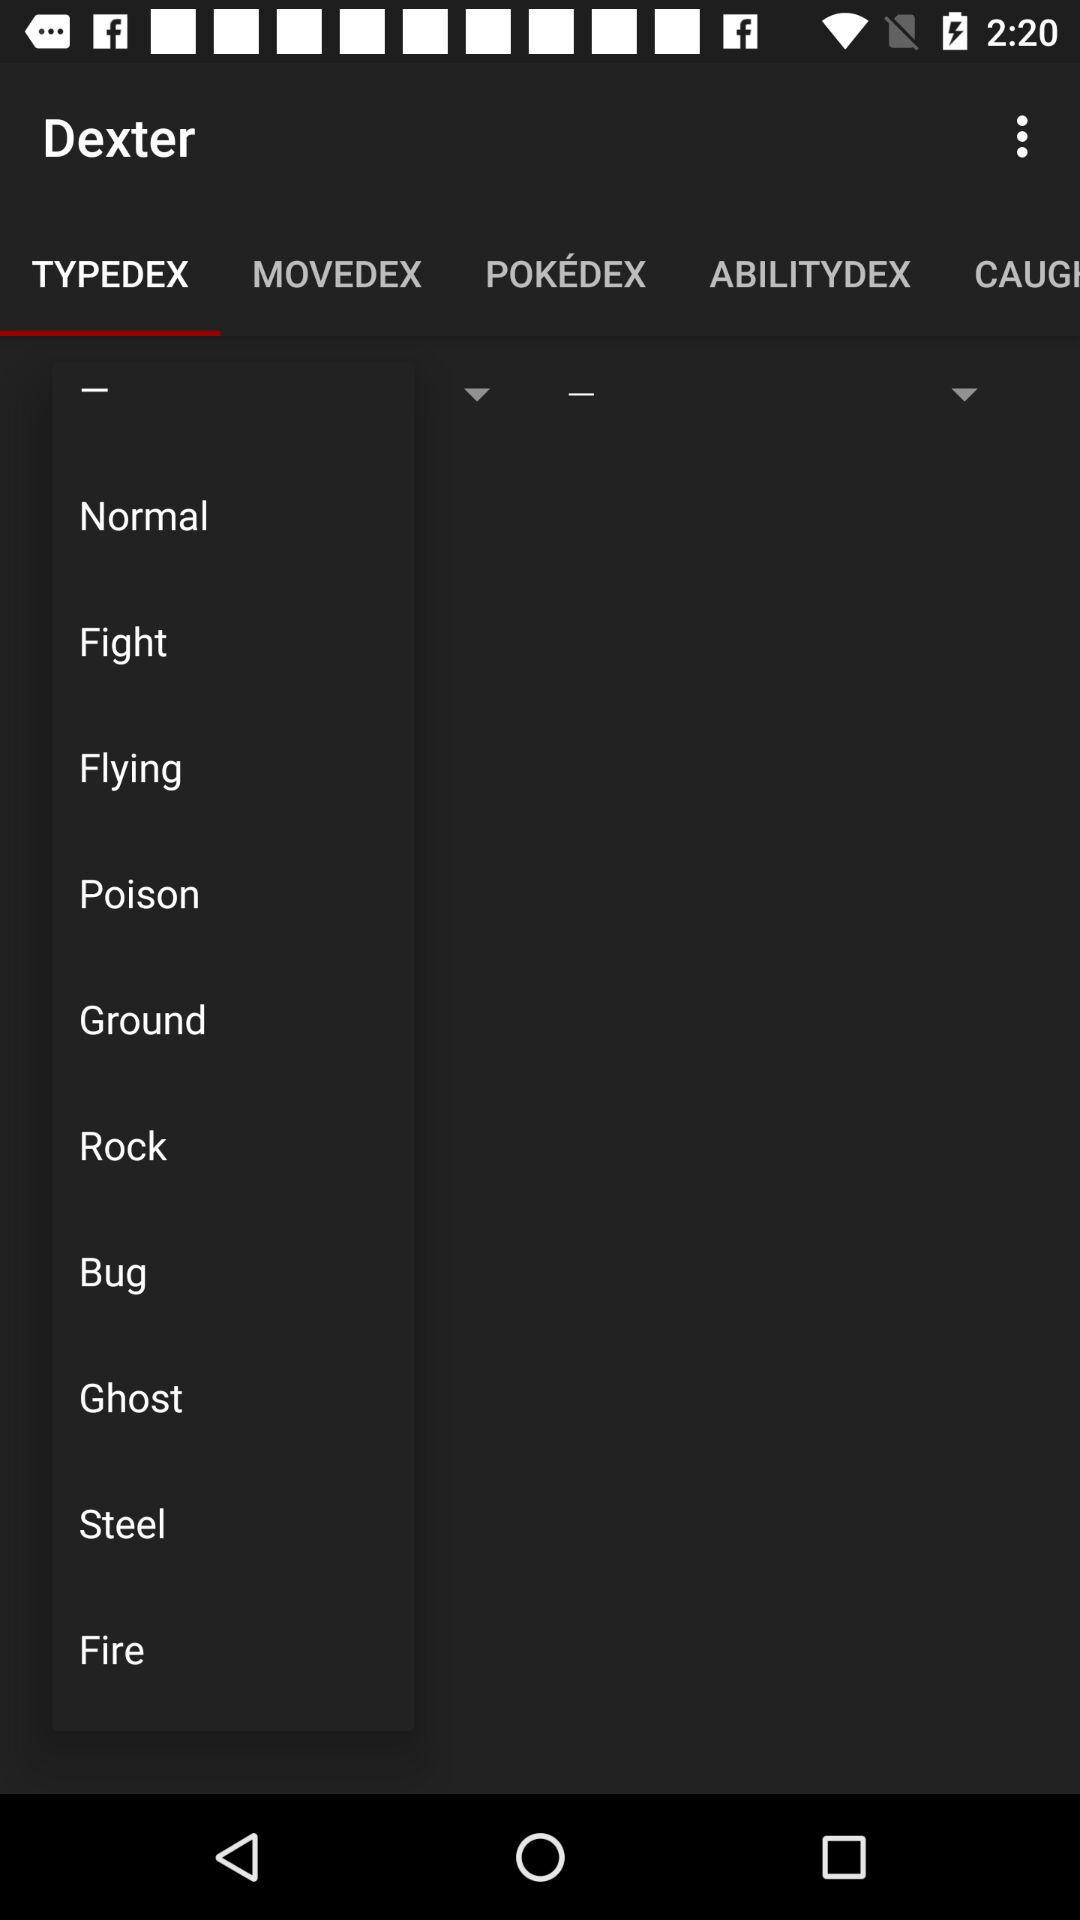Which tab is selected? The selected tab is "TYPEDEX". 